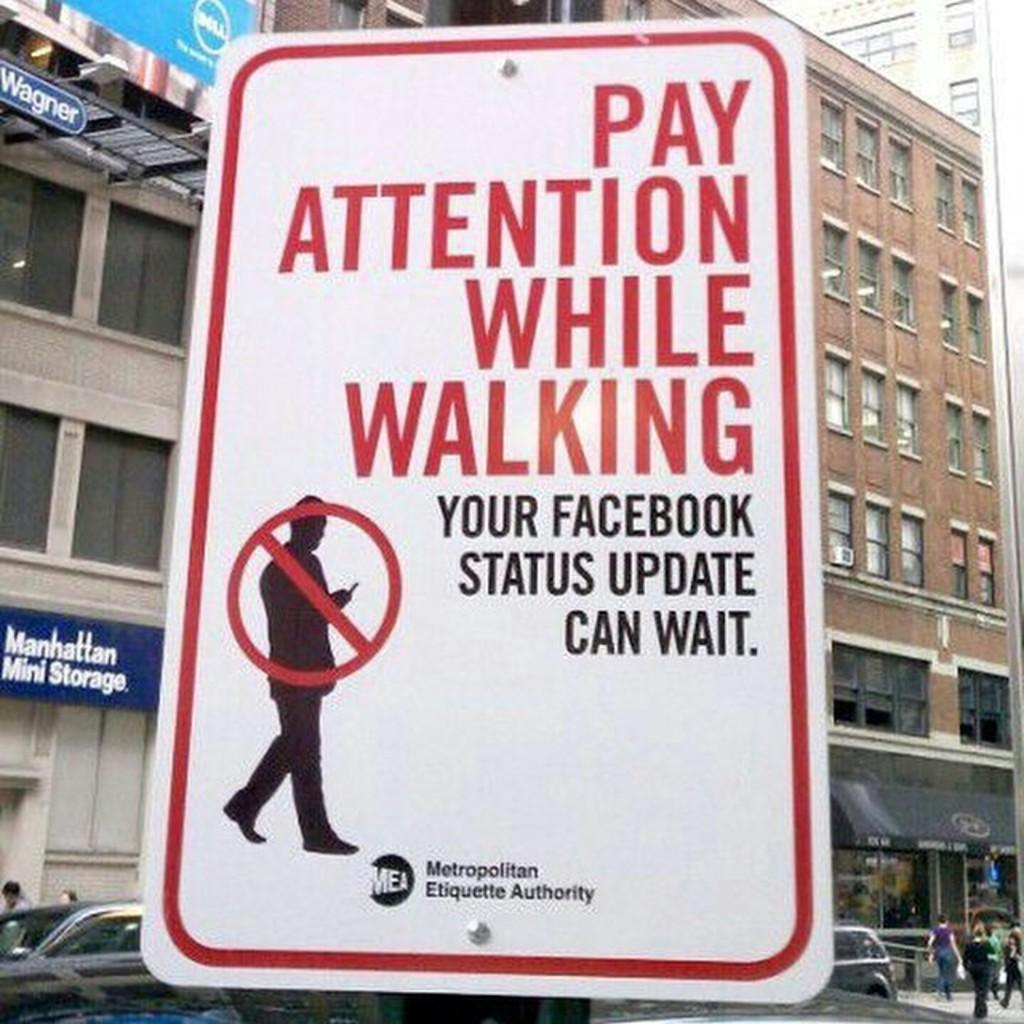<image>
Relay a brief, clear account of the picture shown. A caution sign warning to pay attention while walking. 